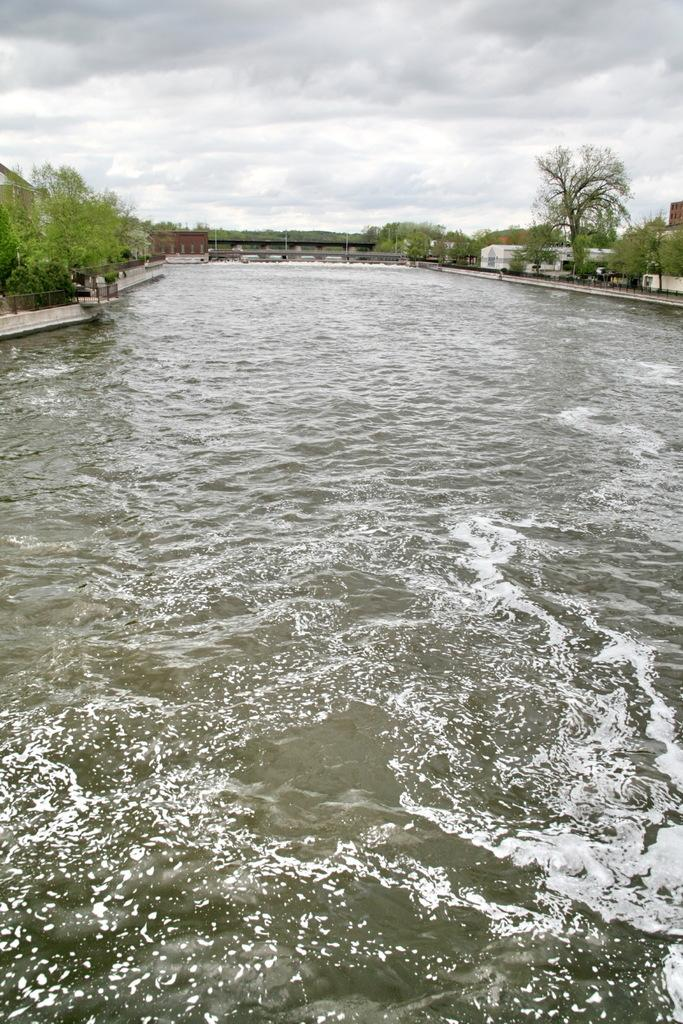What is visible in the image? Water is visible in the image. What can be seen in the background of the image? There are trees and buildings in the background of the image. What is the color of the trees? The trees are green. What is the color of the sky in the image? The sky is white in color. Where is the prison located in the image? There is no prison present in the image. What type of art can be seen on the trees in the image? There is no art visible on the trees in the image. 